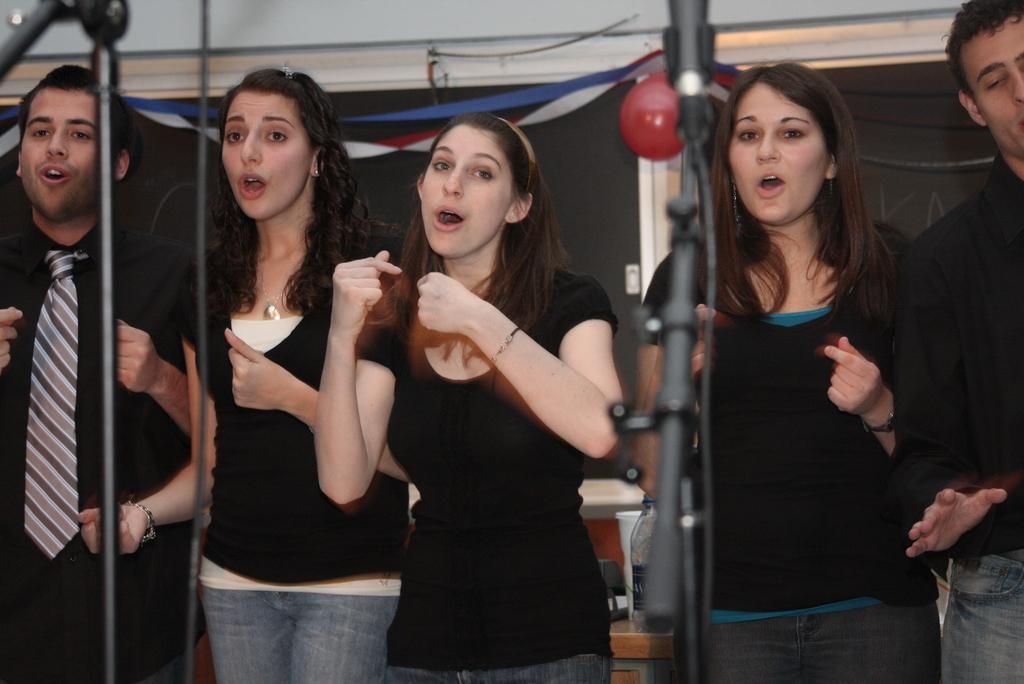Describe this image in one or two sentences. In this picture we can see group of people, in front of them we can see microphones, in the background we can find a balloon and a water bottle. 